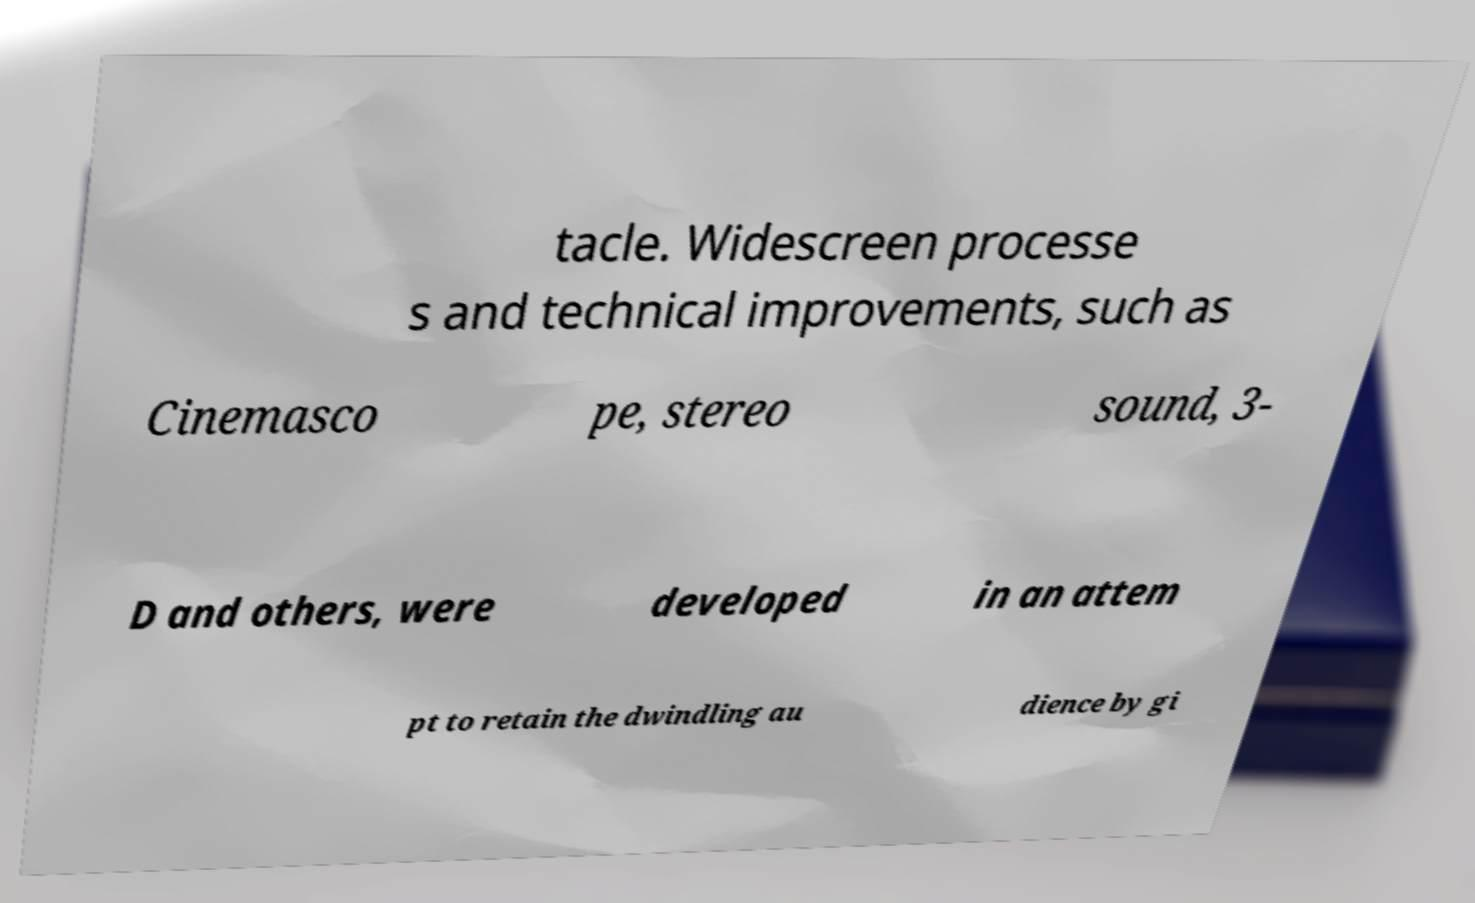Please read and relay the text visible in this image. What does it say? tacle. Widescreen processe s and technical improvements, such as Cinemasco pe, stereo sound, 3- D and others, were developed in an attem pt to retain the dwindling au dience by gi 